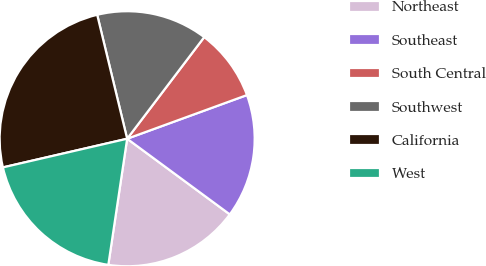Convert chart to OTSL. <chart><loc_0><loc_0><loc_500><loc_500><pie_chart><fcel>Northeast<fcel>Southeast<fcel>South Central<fcel>Southwest<fcel>California<fcel>West<nl><fcel>17.25%<fcel>15.67%<fcel>9.11%<fcel>14.1%<fcel>24.83%<fcel>19.03%<nl></chart> 